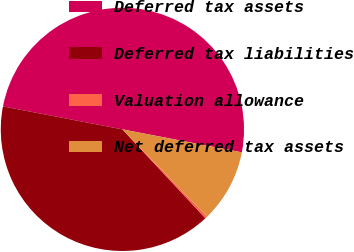<chart> <loc_0><loc_0><loc_500><loc_500><pie_chart><fcel>Deferred tax assets<fcel>Deferred tax liabilities<fcel>Valuation allowance<fcel>Net deferred tax assets<nl><fcel>50.0%<fcel>39.98%<fcel>0.31%<fcel>9.71%<nl></chart> 